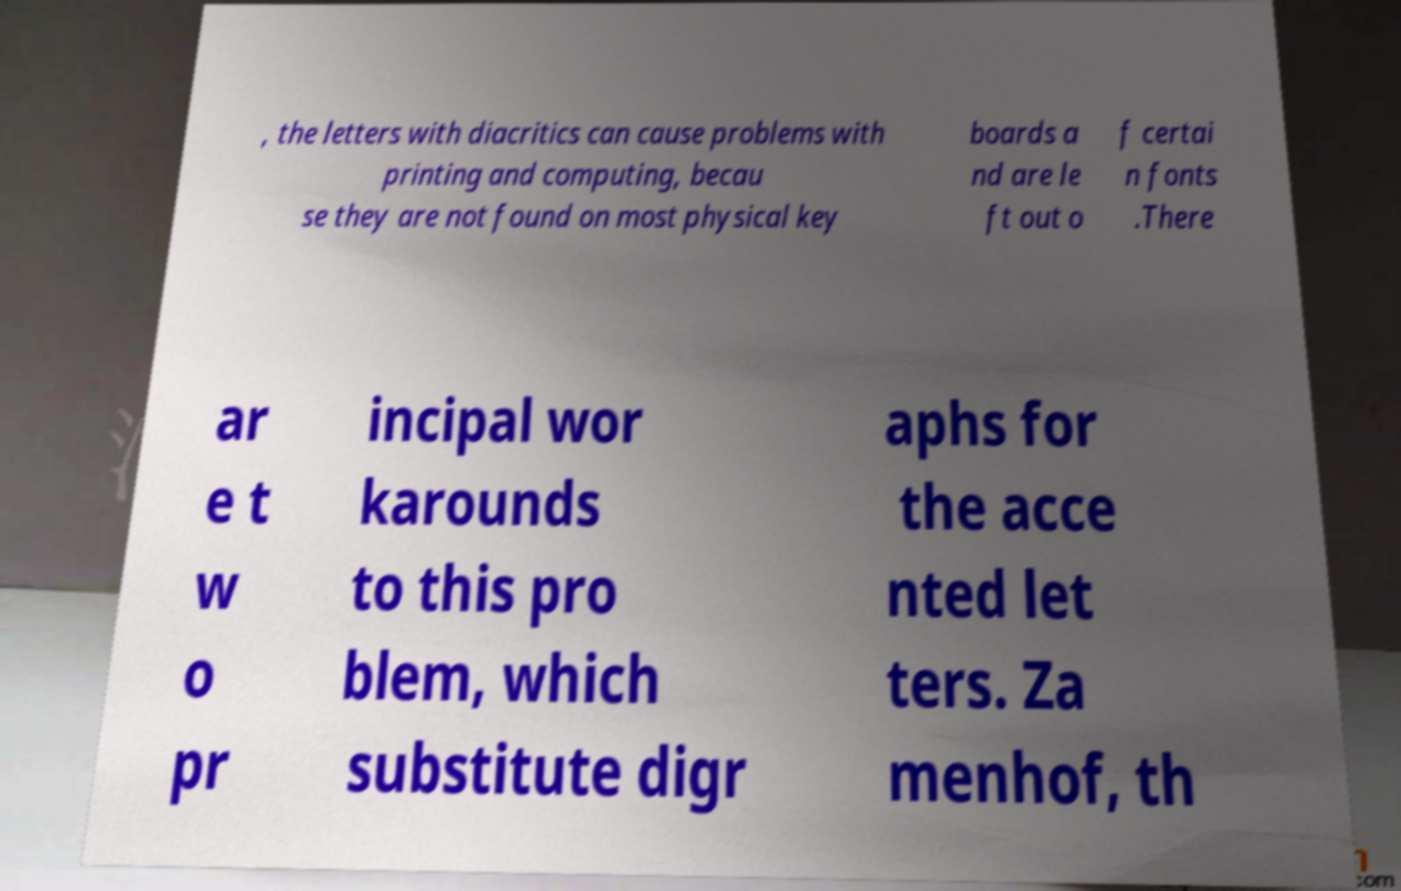Can you read and provide the text displayed in the image?This photo seems to have some interesting text. Can you extract and type it out for me? , the letters with diacritics can cause problems with printing and computing, becau se they are not found on most physical key boards a nd are le ft out o f certai n fonts .There ar e t w o pr incipal wor karounds to this pro blem, which substitute digr aphs for the acce nted let ters. Za menhof, th 